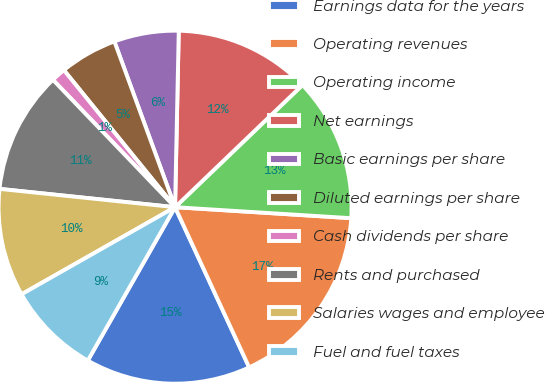Convert chart to OTSL. <chart><loc_0><loc_0><loc_500><loc_500><pie_chart><fcel>Earnings data for the years<fcel>Operating revenues<fcel>Operating income<fcel>Net earnings<fcel>Basic earnings per share<fcel>Diluted earnings per share<fcel>Cash dividends per share<fcel>Rents and purchased<fcel>Salaries wages and employee<fcel>Fuel and fuel taxes<nl><fcel>15.13%<fcel>17.11%<fcel>13.16%<fcel>12.5%<fcel>5.92%<fcel>5.26%<fcel>1.32%<fcel>11.18%<fcel>9.87%<fcel>8.55%<nl></chart> 